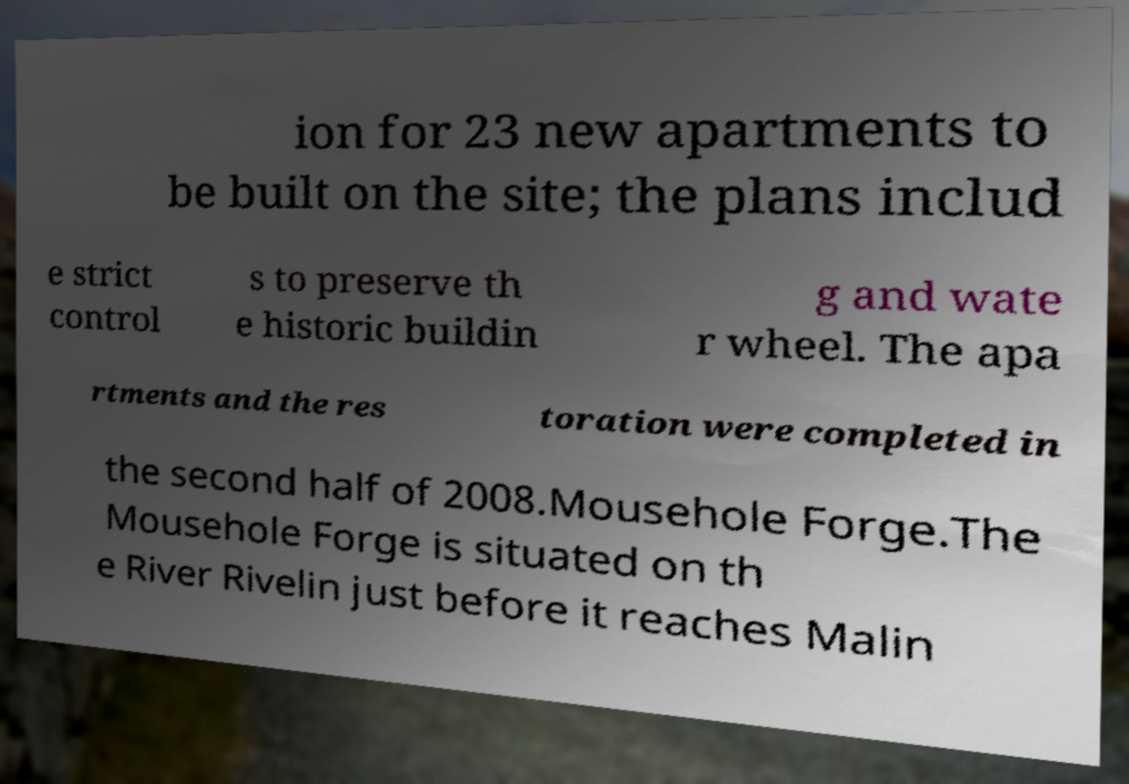There's text embedded in this image that I need extracted. Can you transcribe it verbatim? ion for 23 new apartments to be built on the site; the plans includ e strict control s to preserve th e historic buildin g and wate r wheel. The apa rtments and the res toration were completed in the second half of 2008.Mousehole Forge.The Mousehole Forge is situated on th e River Rivelin just before it reaches Malin 